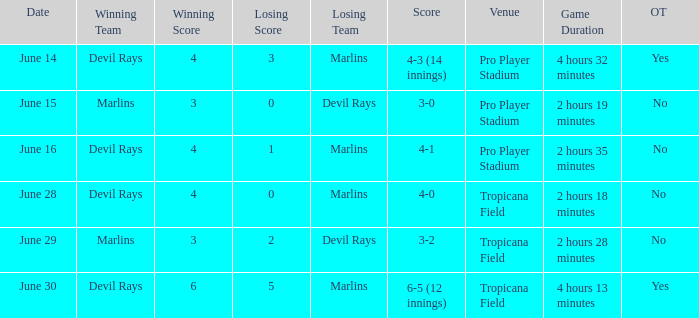What was the score of the game at pro player stadium on june 14? 4-3 (14 innings). Would you mind parsing the complete table? {'header': ['Date', 'Winning Team', 'Winning Score', 'Losing Score', 'Losing Team', 'Score', 'Venue', 'Game Duration', 'OT '], 'rows': [['June 14', 'Devil Rays', '4', '3', 'Marlins', '4-3 (14 innings)', 'Pro Player Stadium', '4 hours 32 minutes', 'Yes'], ['June 15', 'Marlins', '3', '0', 'Devil Rays', '3-0', 'Pro Player Stadium', '2 hours 19 minutes', 'No'], ['June 16', 'Devil Rays', '4', '1', 'Marlins', '4-1', 'Pro Player Stadium', '2 hours 35 minutes', 'No'], ['June 28', 'Devil Rays', '4', '0', 'Marlins', '4-0', 'Tropicana Field', '2 hours 18 minutes', 'No '], ['June 29', 'Marlins', '3', '2', 'Devil Rays', '3-2', 'Tropicana Field', '2 hours 28 minutes', 'No '], ['June 30', 'Devil Rays', '6', '5', 'Marlins', '6-5 (12 innings)', 'Tropicana Field', '4 hours 13 minutes', 'Yes']]} 